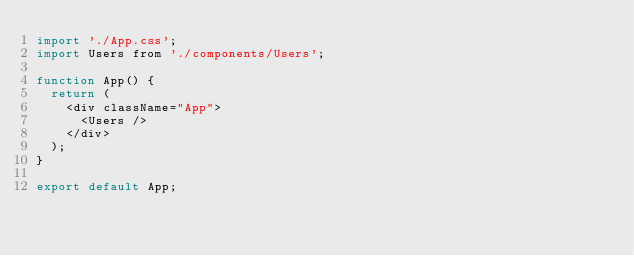Convert code to text. <code><loc_0><loc_0><loc_500><loc_500><_JavaScript_>import './App.css';
import Users from './components/Users';

function App() {
  return (
    <div className="App">
      <Users />
    </div>
  );
}

export default App;
</code> 